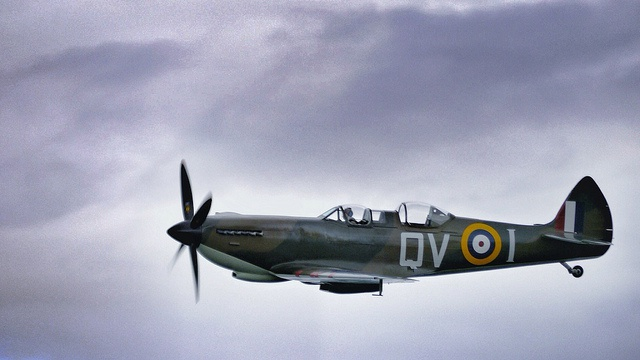Describe the objects in this image and their specific colors. I can see airplane in darkgray, black, and purple tones and people in darkgray, gray, black, and darkblue tones in this image. 